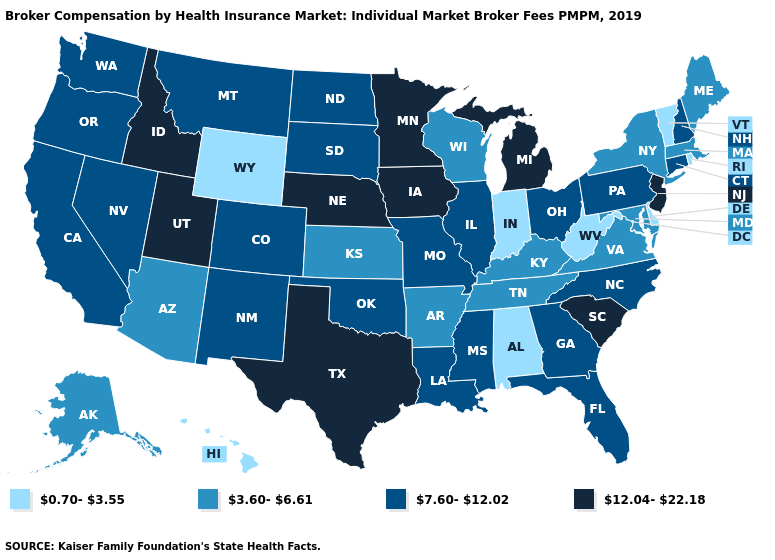Does the map have missing data?
Keep it brief. No. Name the states that have a value in the range 3.60-6.61?
Answer briefly. Alaska, Arizona, Arkansas, Kansas, Kentucky, Maine, Maryland, Massachusetts, New York, Tennessee, Virginia, Wisconsin. What is the lowest value in states that border North Carolina?
Keep it brief. 3.60-6.61. How many symbols are there in the legend?
Short answer required. 4. What is the highest value in the USA?
Quick response, please. 12.04-22.18. Name the states that have a value in the range 12.04-22.18?
Write a very short answer. Idaho, Iowa, Michigan, Minnesota, Nebraska, New Jersey, South Carolina, Texas, Utah. Among the states that border New Hampshire , does Vermont have the lowest value?
Be succinct. Yes. Does Maine have the lowest value in the Northeast?
Keep it brief. No. What is the value of New Mexico?
Give a very brief answer. 7.60-12.02. Is the legend a continuous bar?
Quick response, please. No. Name the states that have a value in the range 7.60-12.02?
Keep it brief. California, Colorado, Connecticut, Florida, Georgia, Illinois, Louisiana, Mississippi, Missouri, Montana, Nevada, New Hampshire, New Mexico, North Carolina, North Dakota, Ohio, Oklahoma, Oregon, Pennsylvania, South Dakota, Washington. Name the states that have a value in the range 3.60-6.61?
Quick response, please. Alaska, Arizona, Arkansas, Kansas, Kentucky, Maine, Maryland, Massachusetts, New York, Tennessee, Virginia, Wisconsin. Which states have the lowest value in the USA?
Keep it brief. Alabama, Delaware, Hawaii, Indiana, Rhode Island, Vermont, West Virginia, Wyoming. What is the highest value in states that border Tennessee?
Write a very short answer. 7.60-12.02. Does the first symbol in the legend represent the smallest category?
Concise answer only. Yes. 